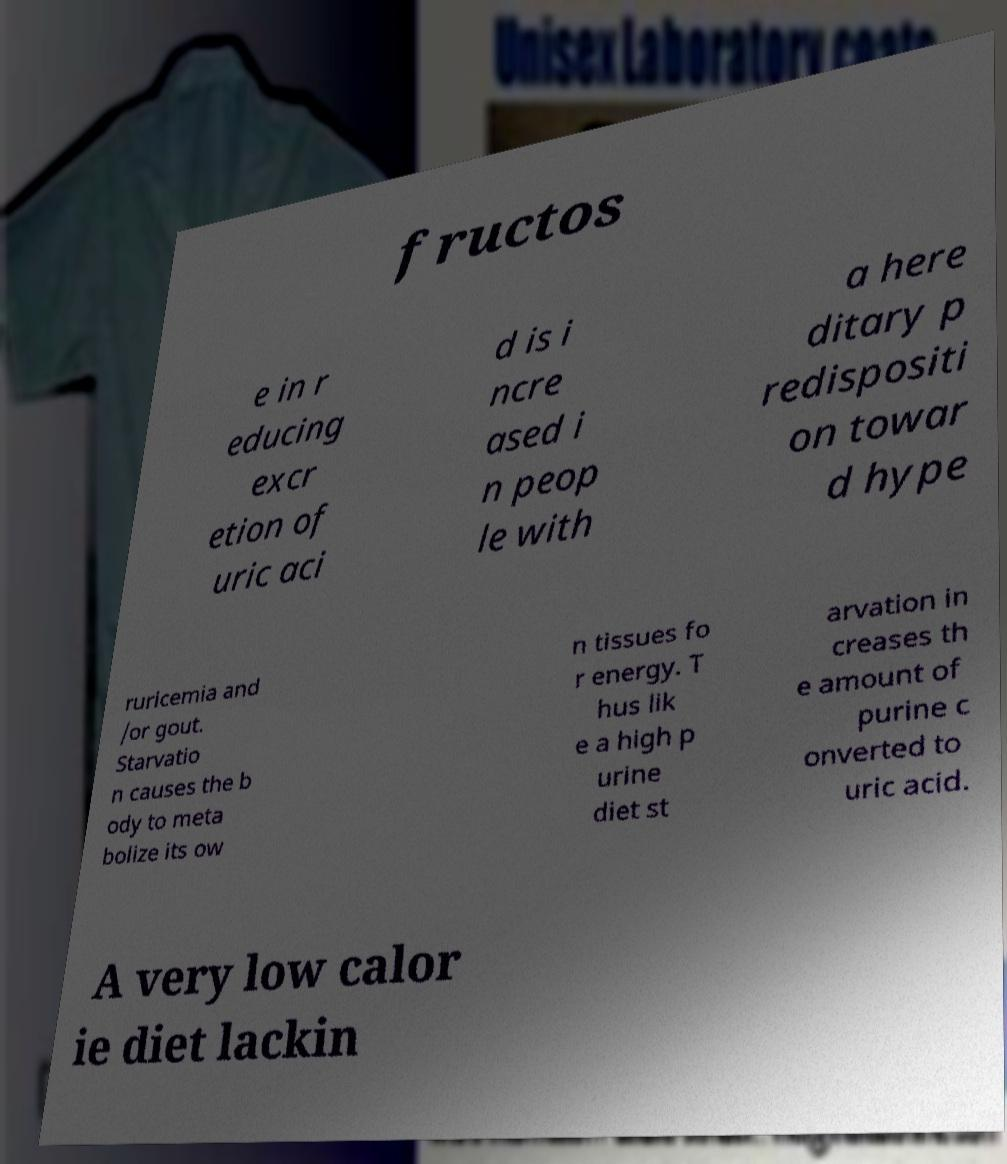Could you assist in decoding the text presented in this image and type it out clearly? fructos e in r educing excr etion of uric aci d is i ncre ased i n peop le with a here ditary p redispositi on towar d hype ruricemia and /or gout. Starvatio n causes the b ody to meta bolize its ow n tissues fo r energy. T hus lik e a high p urine diet st arvation in creases th e amount of purine c onverted to uric acid. A very low calor ie diet lackin 